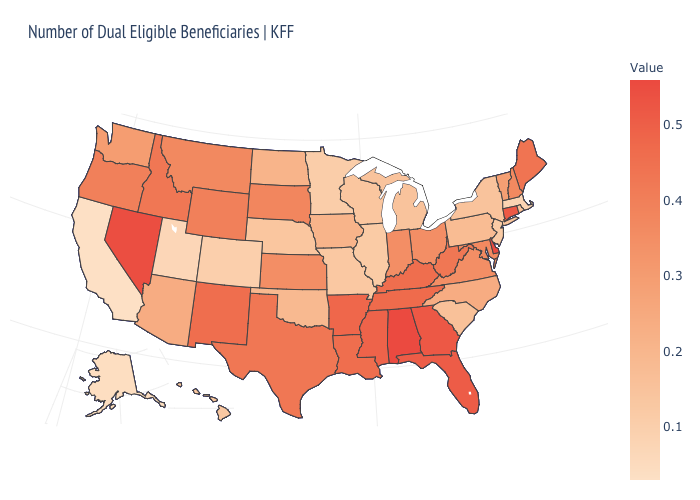Does Nebraska have the lowest value in the MidWest?
Short answer required. No. Which states have the highest value in the USA?
Answer briefly. Alabama, Delaware. Does California have the lowest value in the USA?
Quick response, please. Yes. Does the map have missing data?
Write a very short answer. No. Among the states that border New Jersey , which have the lowest value?
Write a very short answer. New York. Is the legend a continuous bar?
Answer briefly. Yes. 